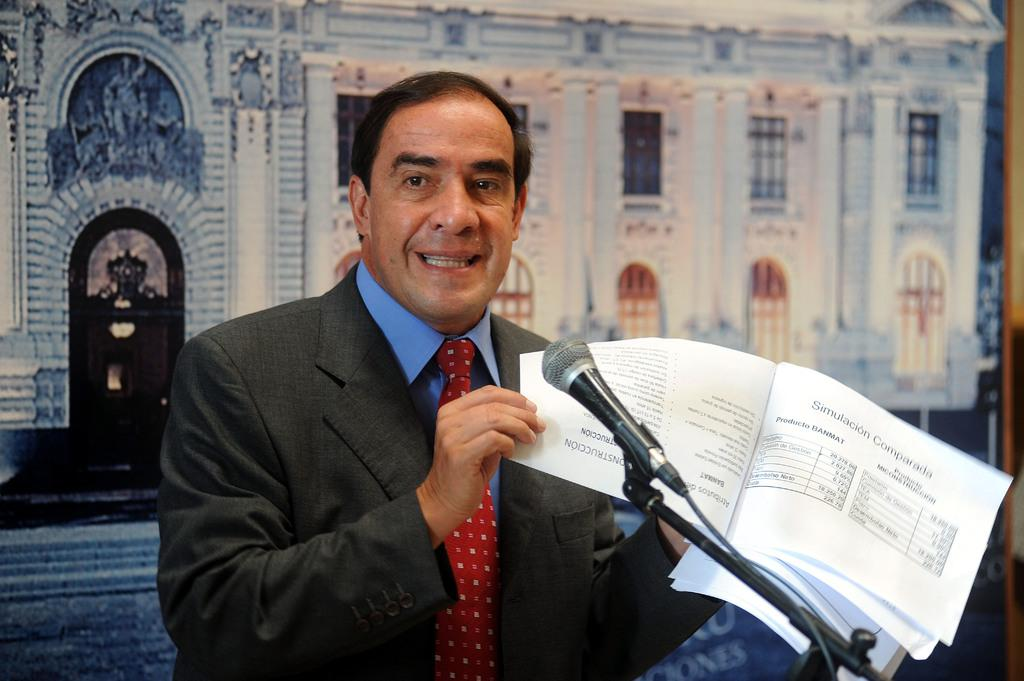Who is present in the image? There is a man in the image. What is the man holding in his hands? The man is holding papers in his hands. What object is present for amplifying sound in the image? There is a microphone on a stand in the image. What can be seen in the background of the image? There is a picture of a building, windows, and doors visible in the background. What type of fruit is hanging from the microphone in the image? There is no fruit hanging from the microphone in the image. 